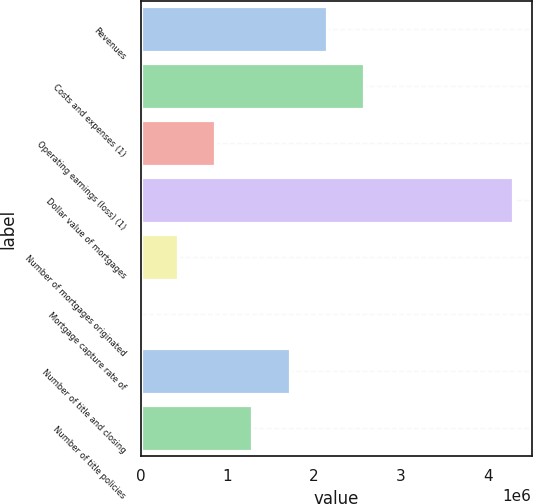Convert chart to OTSL. <chart><loc_0><loc_0><loc_500><loc_500><bar_chart><fcel>Revenues<fcel>Costs and expenses (1)<fcel>Operating earnings (loss) (1)<fcel>Dollar value of mortgages<fcel>Number of mortgages originated<fcel>Mortgage capture rate of<fcel>Number of title and closing<fcel>Number of title policies<nl><fcel>2.14504e+06<fcel>2.57403e+06<fcel>858068<fcel>4.29e+06<fcel>429076<fcel>85<fcel>1.71605e+06<fcel>1.28706e+06<nl></chart> 